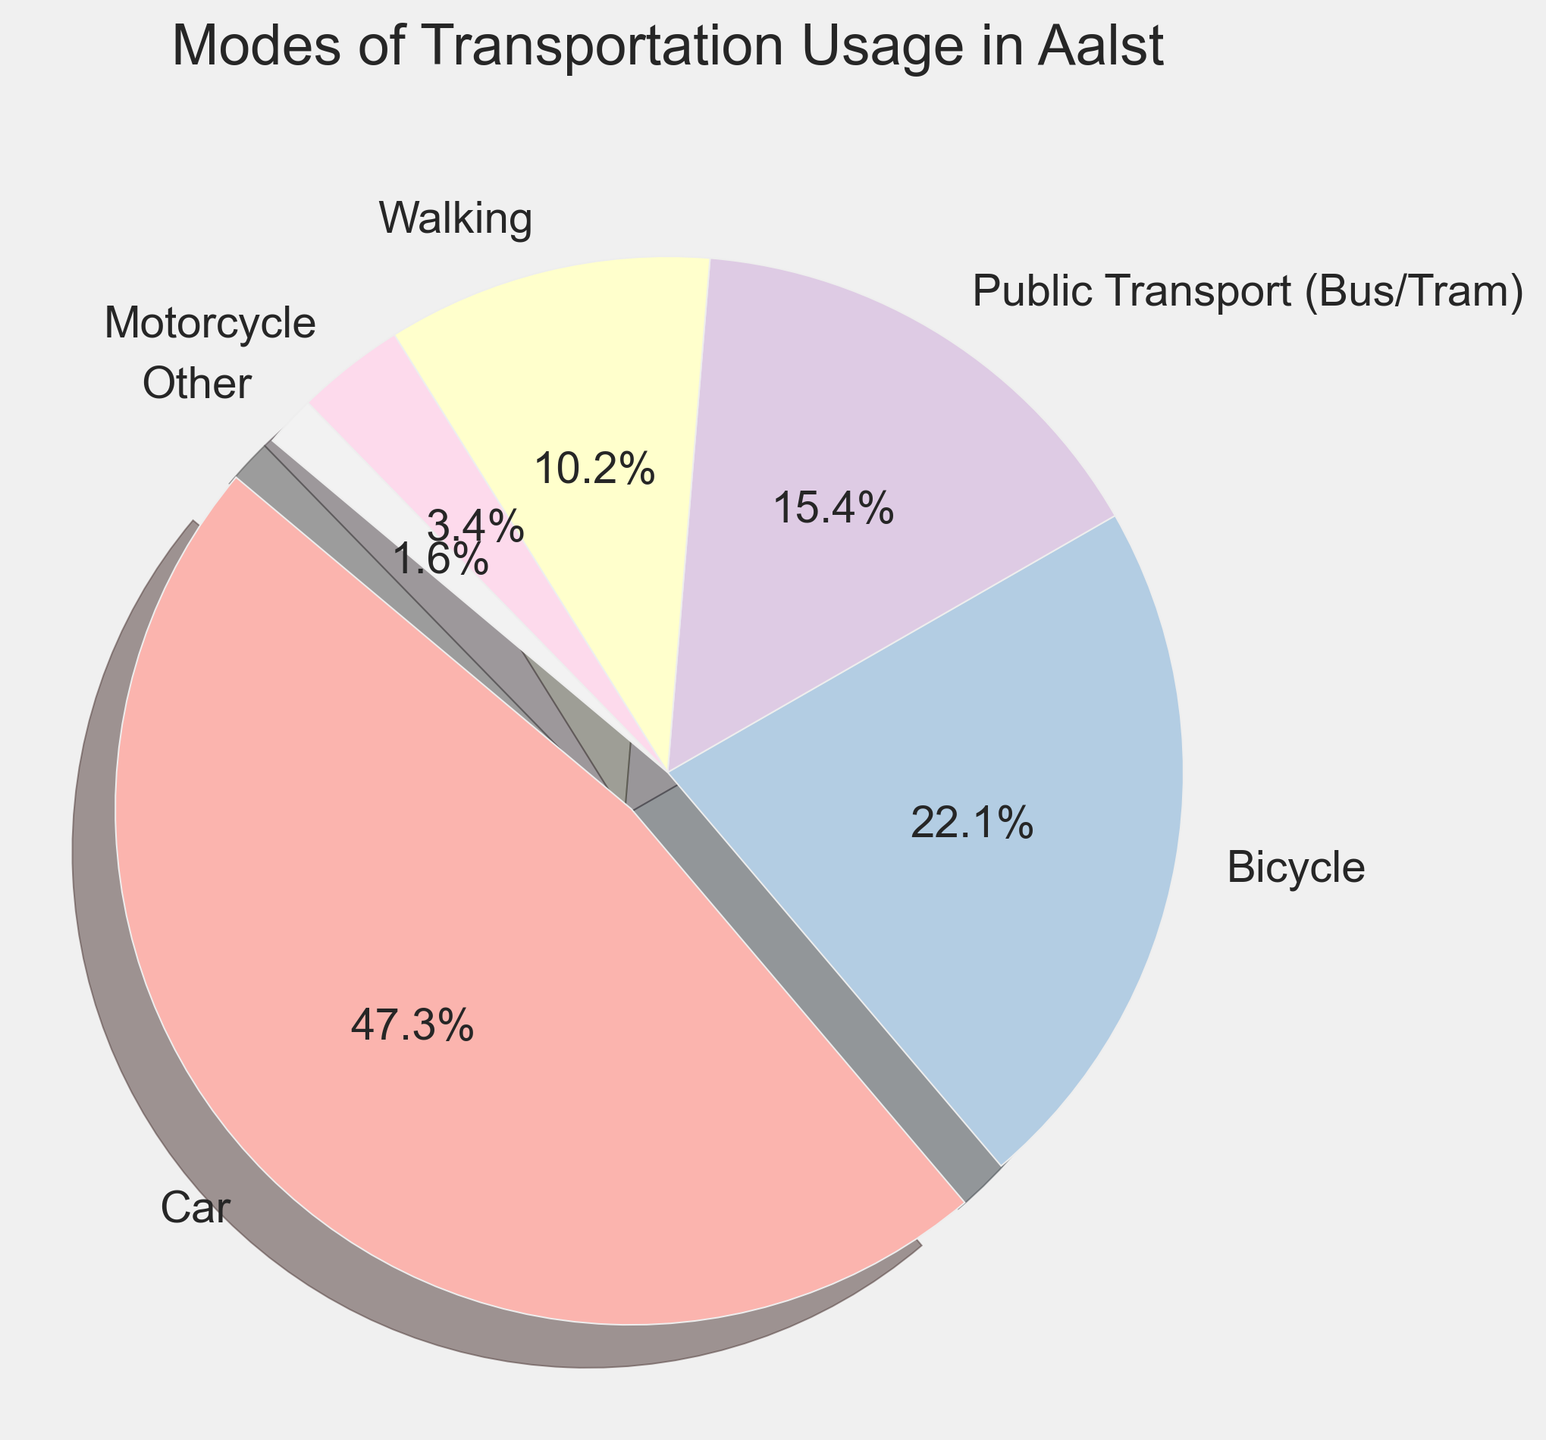What proportion of people use either bicycles or motorcycles? Add the percentages of people who use bicycles (22.1%) and motorcycles (3.4%). 22.1 + 3.4 = 25.5
Answer: 25.5% Which mode of transportation has the highest percentage usage? By inspecting the figure, the largest segment is represented by the car. Its percentage is 47.3%.
Answer: Car What is the difference in percentage points between car usage and public transport usage? Subtract the percentage of public transport usage (15.4%) from the percentage of car usage (47.3%). 47.3 - 15.4 = 31.9
Answer: 31.9 How does the percentage of people using public transport compare to those walking? From the figure, public transport usage is 15.4%, while walking is 10.2%. By comparing them, public transport usage is greater than walking by 15.4 - 10.2 = 5.2 percentage points.
Answer: Public transport usage is higher by 5.2 percentage points What fraction of the transportation modes constitute less than 5% of usage? Identify all modes with less than 5% usage: motorcycle (3.4%) and other (1.6%). Sum their percentages: 3.4 + 1.6 = 5.0. Then, find the fraction these modes represent out of the total 100%: 5.0/100 = 0.05
Answer: 0.05 or 5% How much larger is the percentage of bicycle users compared to motorcycle users? Subtract the motorcycle usage percentage (3.4%) from the bicycle usage percentage (22.1%). 22.1 - 3.4 = 18.7
Answer: 18.7 What percentage of the total does 'Other' transportation account for? From the figure, find the percentage labeled 'Other,' which is 1.6%.
Answer: 1.6% By how much does the usage of walking lag behind that of cars? Subtract the walking percentage (10.2%) from the car percentage (47.3%). 47.3 - 10.2 = 37.1
Answer: 37.1 Which two modes of transportation add up to more than half of the total transportation usage? Identify the two highest percentages: car (47.3%) and bicycle (22.1%). Sum their percentages: 47.3 + 22.1 = 69.4, which is more than 50% of the total.
Answer: Car and Bicycle 